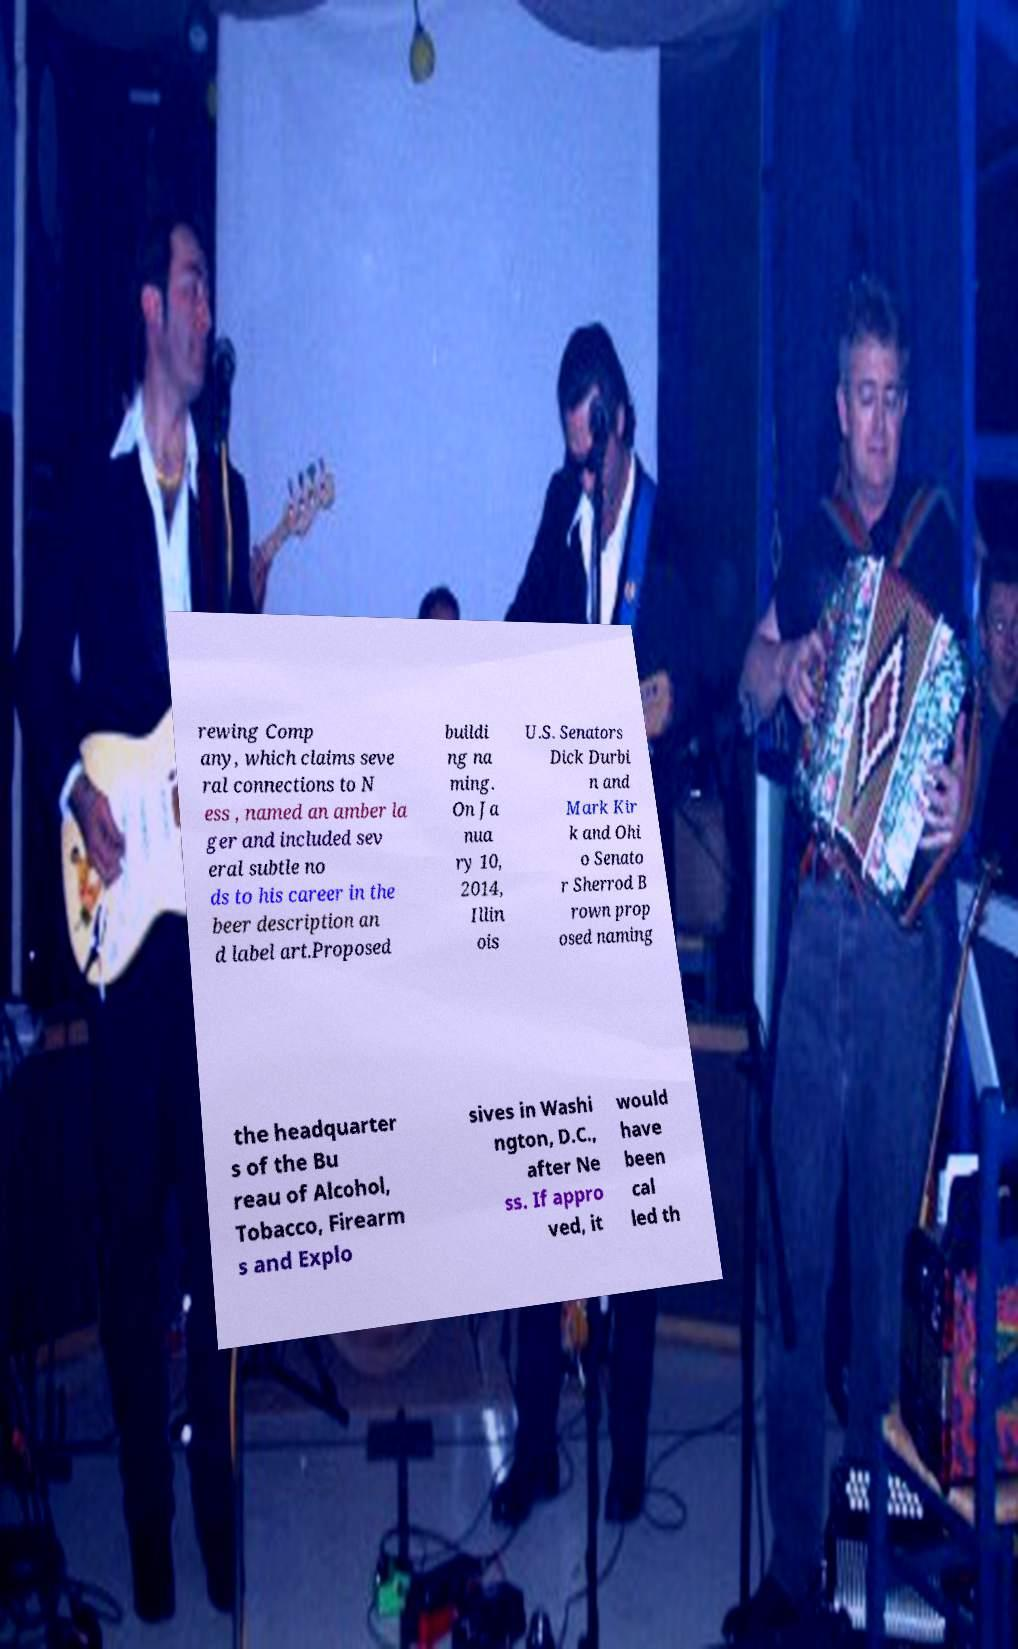Can you read and provide the text displayed in the image?This photo seems to have some interesting text. Can you extract and type it out for me? rewing Comp any, which claims seve ral connections to N ess , named an amber la ger and included sev eral subtle no ds to his career in the beer description an d label art.Proposed buildi ng na ming. On Ja nua ry 10, 2014, Illin ois U.S. Senators Dick Durbi n and Mark Kir k and Ohi o Senato r Sherrod B rown prop osed naming the headquarter s of the Bu reau of Alcohol, Tobacco, Firearm s and Explo sives in Washi ngton, D.C., after Ne ss. If appro ved, it would have been cal led th 